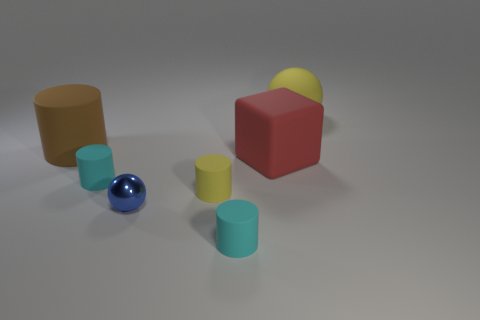Is there a large thing to the right of the tiny cyan matte thing right of the blue object?
Your answer should be very brief. Yes. There is a brown object that is the same size as the red cube; what is its material?
Your response must be concise. Rubber. Is there a purple rubber ball of the same size as the blue thing?
Your answer should be compact. No. There is a small cyan cylinder on the right side of the metal thing; what is its material?
Your answer should be very brief. Rubber. Do the object that is behind the large brown object and the large red block have the same material?
Your answer should be compact. Yes. The shiny thing that is the same size as the yellow matte cylinder is what shape?
Give a very brief answer. Sphere. What number of matte objects are the same color as the large rubber sphere?
Offer a very short reply. 1. Are there fewer objects that are in front of the big brown matte thing than tiny spheres on the right side of the blue metal sphere?
Provide a short and direct response. No. Are there any small metallic objects behind the large brown cylinder?
Give a very brief answer. No. There is a small cyan thing to the left of the cyan object in front of the blue shiny object; are there any big red things right of it?
Ensure brevity in your answer.  Yes. 